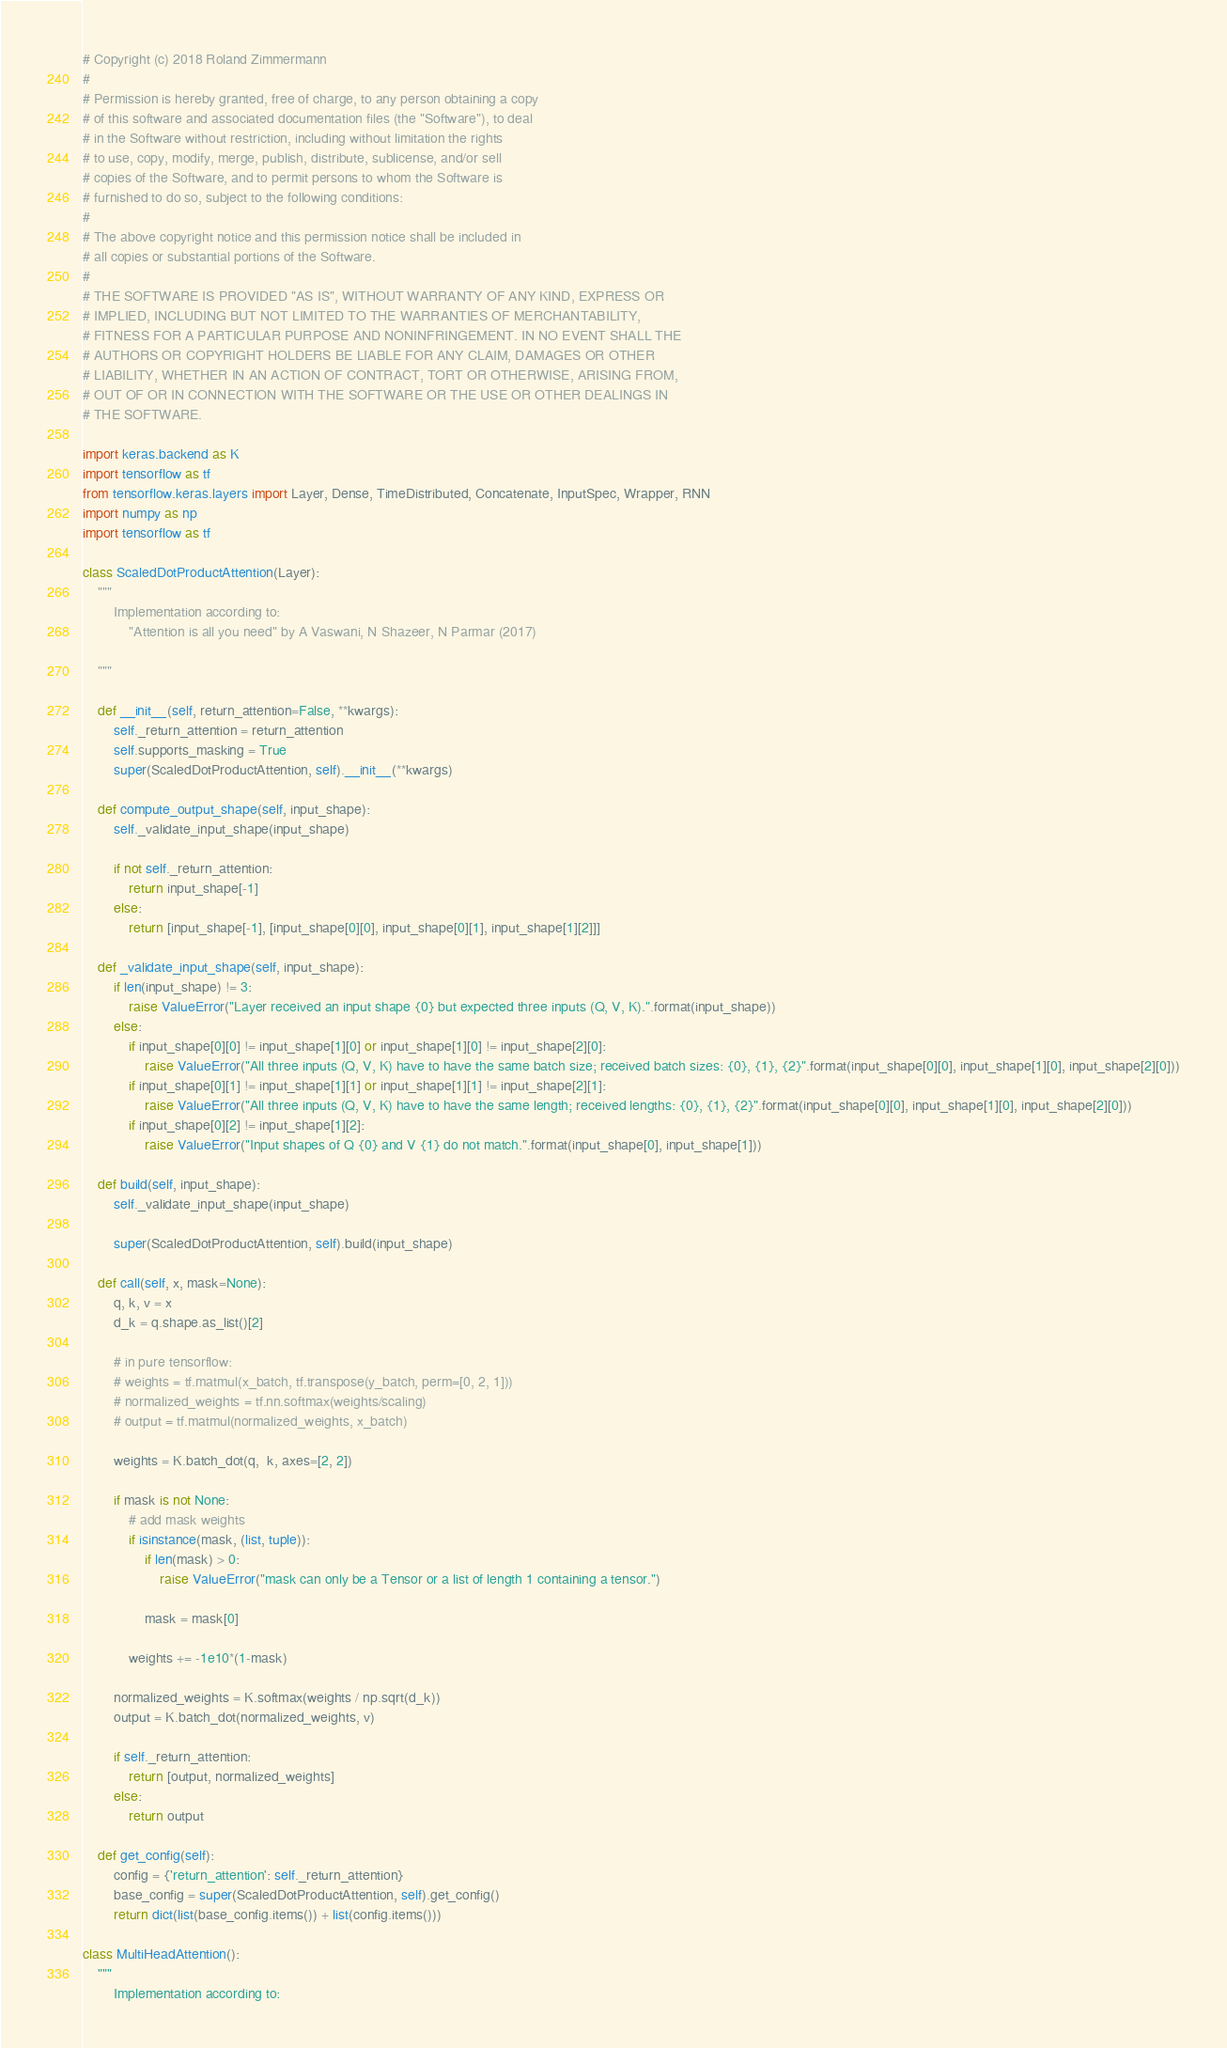<code> <loc_0><loc_0><loc_500><loc_500><_Python_># Copyright (c) 2018 Roland Zimmermann
#
# Permission is hereby granted, free of charge, to any person obtaining a copy
# of this software and associated documentation files (the "Software"), to deal
# in the Software without restriction, including without limitation the rights
# to use, copy, modify, merge, publish, distribute, sublicense, and/or sell
# copies of the Software, and to permit persons to whom the Software is
# furnished to do so, subject to the following conditions:
#
# The above copyright notice and this permission notice shall be included in
# all copies or substantial portions of the Software.
#
# THE SOFTWARE IS PROVIDED "AS IS", WITHOUT WARRANTY OF ANY KIND, EXPRESS OR
# IMPLIED, INCLUDING BUT NOT LIMITED TO THE WARRANTIES OF MERCHANTABILITY,
# FITNESS FOR A PARTICULAR PURPOSE AND NONINFRINGEMENT. IN NO EVENT SHALL THE
# AUTHORS OR COPYRIGHT HOLDERS BE LIABLE FOR ANY CLAIM, DAMAGES OR OTHER
# LIABILITY, WHETHER IN AN ACTION OF CONTRACT, TORT OR OTHERWISE, ARISING FROM,
# OUT OF OR IN CONNECTION WITH THE SOFTWARE OR THE USE OR OTHER DEALINGS IN
# THE SOFTWARE.

import keras.backend as K
import tensorflow as tf
from tensorflow.keras.layers import Layer, Dense, TimeDistributed, Concatenate, InputSpec, Wrapper, RNN
import numpy as np
import tensorflow as tf

class ScaledDotProductAttention(Layer):
    """
        Implementation according to:
            "Attention is all you need" by A Vaswani, N Shazeer, N Parmar (2017)

    """

    def __init__(self, return_attention=False, **kwargs):
        self._return_attention = return_attention
        self.supports_masking = True
        super(ScaledDotProductAttention, self).__init__(**kwargs)

    def compute_output_shape(self, input_shape):
        self._validate_input_shape(input_shape)

        if not self._return_attention:
            return input_shape[-1]
        else:
            return [input_shape[-1], [input_shape[0][0], input_shape[0][1], input_shape[1][2]]]

    def _validate_input_shape(self, input_shape):
        if len(input_shape) != 3:
            raise ValueError("Layer received an input shape {0} but expected three inputs (Q, V, K).".format(input_shape))
        else:
            if input_shape[0][0] != input_shape[1][0] or input_shape[1][0] != input_shape[2][0]:
                raise ValueError("All three inputs (Q, V, K) have to have the same batch size; received batch sizes: {0}, {1}, {2}".format(input_shape[0][0], input_shape[1][0], input_shape[2][0]))
            if input_shape[0][1] != input_shape[1][1] or input_shape[1][1] != input_shape[2][1]:
                raise ValueError("All three inputs (Q, V, K) have to have the same length; received lengths: {0}, {1}, {2}".format(input_shape[0][0], input_shape[1][0], input_shape[2][0]))
            if input_shape[0][2] != input_shape[1][2]:
                raise ValueError("Input shapes of Q {0} and V {1} do not match.".format(input_shape[0], input_shape[1]))

    def build(self, input_shape):
        self._validate_input_shape(input_shape)

        super(ScaledDotProductAttention, self).build(input_shape)

    def call(self, x, mask=None):
        q, k, v = x
        d_k = q.shape.as_list()[2]

        # in pure tensorflow:
        # weights = tf.matmul(x_batch, tf.transpose(y_batch, perm=[0, 2, 1]))
        # normalized_weights = tf.nn.softmax(weights/scaling)
        # output = tf.matmul(normalized_weights, x_batch)

        weights = K.batch_dot(q,  k, axes=[2, 2])

        if mask is not None:
            # add mask weights
            if isinstance(mask, (list, tuple)):
                if len(mask) > 0:
                    raise ValueError("mask can only be a Tensor or a list of length 1 containing a tensor.")

                mask = mask[0]

            weights += -1e10*(1-mask)

        normalized_weights = K.softmax(weights / np.sqrt(d_k))
        output = K.batch_dot(normalized_weights, v)

        if self._return_attention:
            return [output, normalized_weights]
        else:
            return output

    def get_config(self):
        config = {'return_attention': self._return_attention}
        base_config = super(ScaledDotProductAttention, self).get_config()
        return dict(list(base_config.items()) + list(config.items()))

class MultiHeadAttention():
    """
        Implementation according to:</code> 